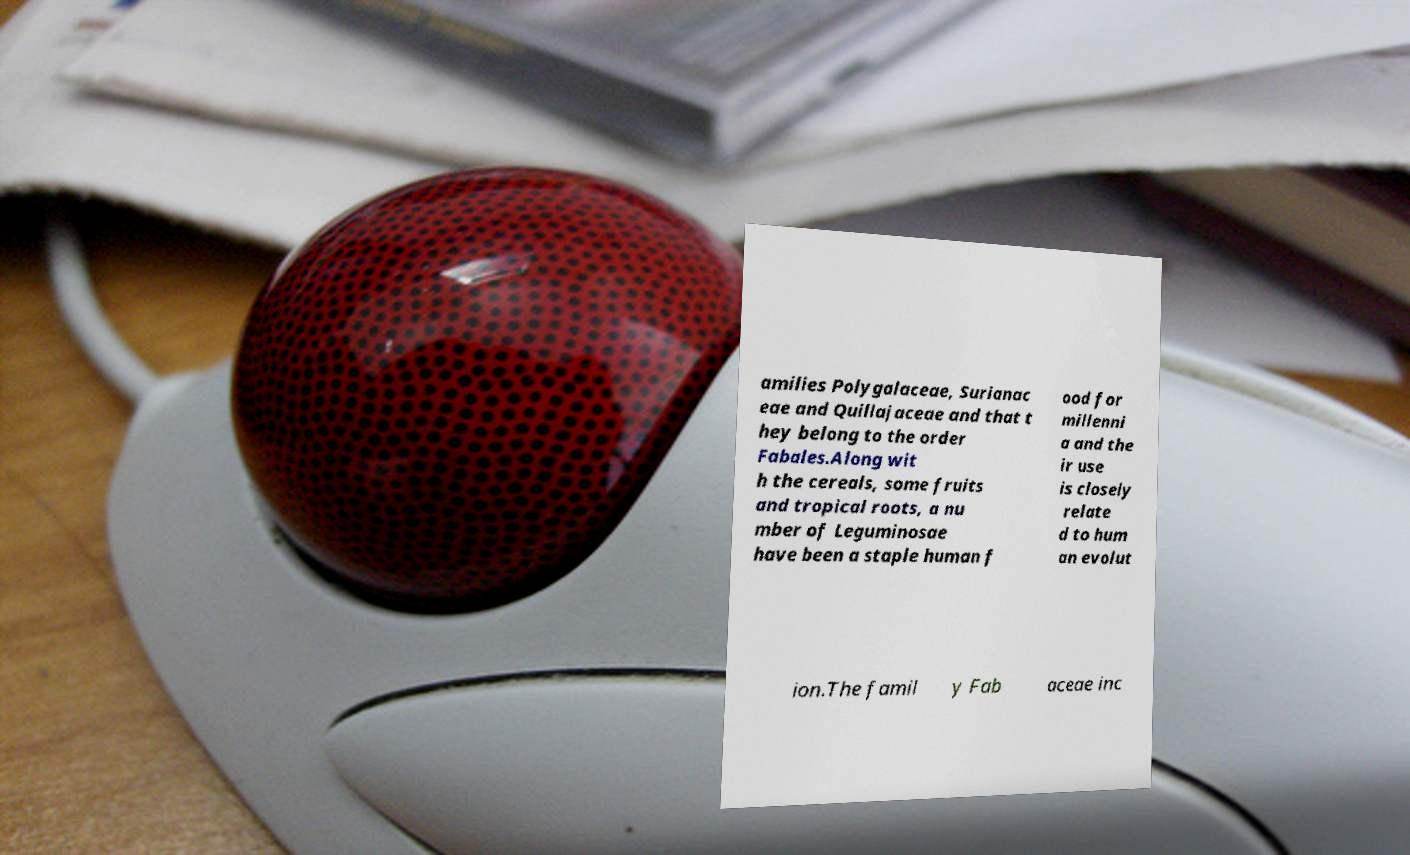Can you read and provide the text displayed in the image?This photo seems to have some interesting text. Can you extract and type it out for me? amilies Polygalaceae, Surianac eae and Quillajaceae and that t hey belong to the order Fabales.Along wit h the cereals, some fruits and tropical roots, a nu mber of Leguminosae have been a staple human f ood for millenni a and the ir use is closely relate d to hum an evolut ion.The famil y Fab aceae inc 